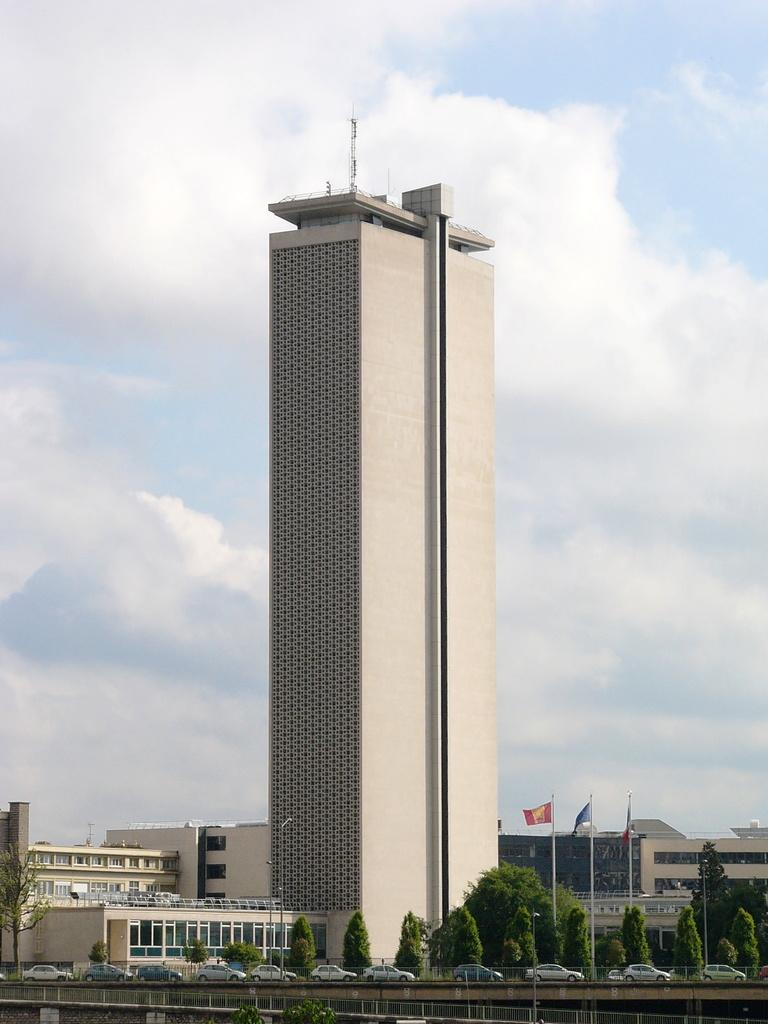What type of structures can be seen in the image? There are multiple buildings in the image. What can be seen flying in the image? There are 3 flags in the image, and they are colorful. What type of vegetation is visible in the image? There are trees visible in the image. What type of vehicles are present in the image? There are cars present in the image. What is visible in the background of the image? The sky is visible in the background of the image. Can you see any seashore or clams in the image? No, there is no seashore or clams present in the image. What type of nut is being used to hold the flags in the image? There are no nuts present in the image; the flags are attached to the buildings or poles. 